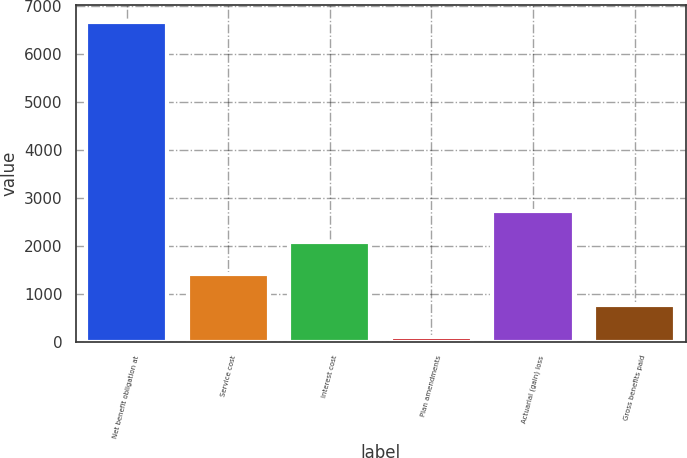<chart> <loc_0><loc_0><loc_500><loc_500><bar_chart><fcel>Net benefit obligation at<fcel>Service cost<fcel>Interest cost<fcel>Plan amendments<fcel>Actuarial (gain) loss<fcel>Gross benefits paid<nl><fcel>6670<fcel>1414<fcel>2071<fcel>100<fcel>2728<fcel>757<nl></chart> 